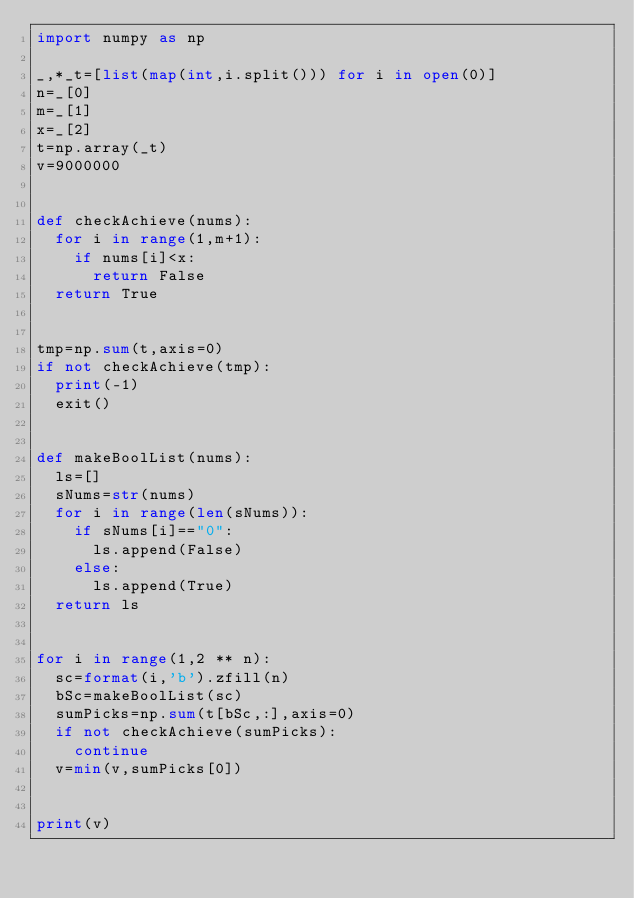<code> <loc_0><loc_0><loc_500><loc_500><_Python_>import numpy as np

_,*_t=[list(map(int,i.split())) for i in open(0)]
n=_[0]
m=_[1]
x=_[2]
t=np.array(_t)
v=9000000


def checkAchieve(nums):
  for i in range(1,m+1):
    if nums[i]<x:
      return False
  return True


tmp=np.sum(t,axis=0)
if not checkAchieve(tmp):
  print(-1)
  exit()

  
def makeBoolList(nums):
  ls=[]
  sNums=str(nums)
  for i in range(len(sNums)):
    if sNums[i]=="0":
      ls.append(False)
    else:
      ls.append(True)
  return ls


for i in range(1,2 ** n):
  sc=format(i,'b').zfill(n)
  bSc=makeBoolList(sc)
  sumPicks=np.sum(t[bSc,:],axis=0)
  if not checkAchieve(sumPicks):
    continue
  v=min(v,sumPicks[0])

  
print(v)</code> 